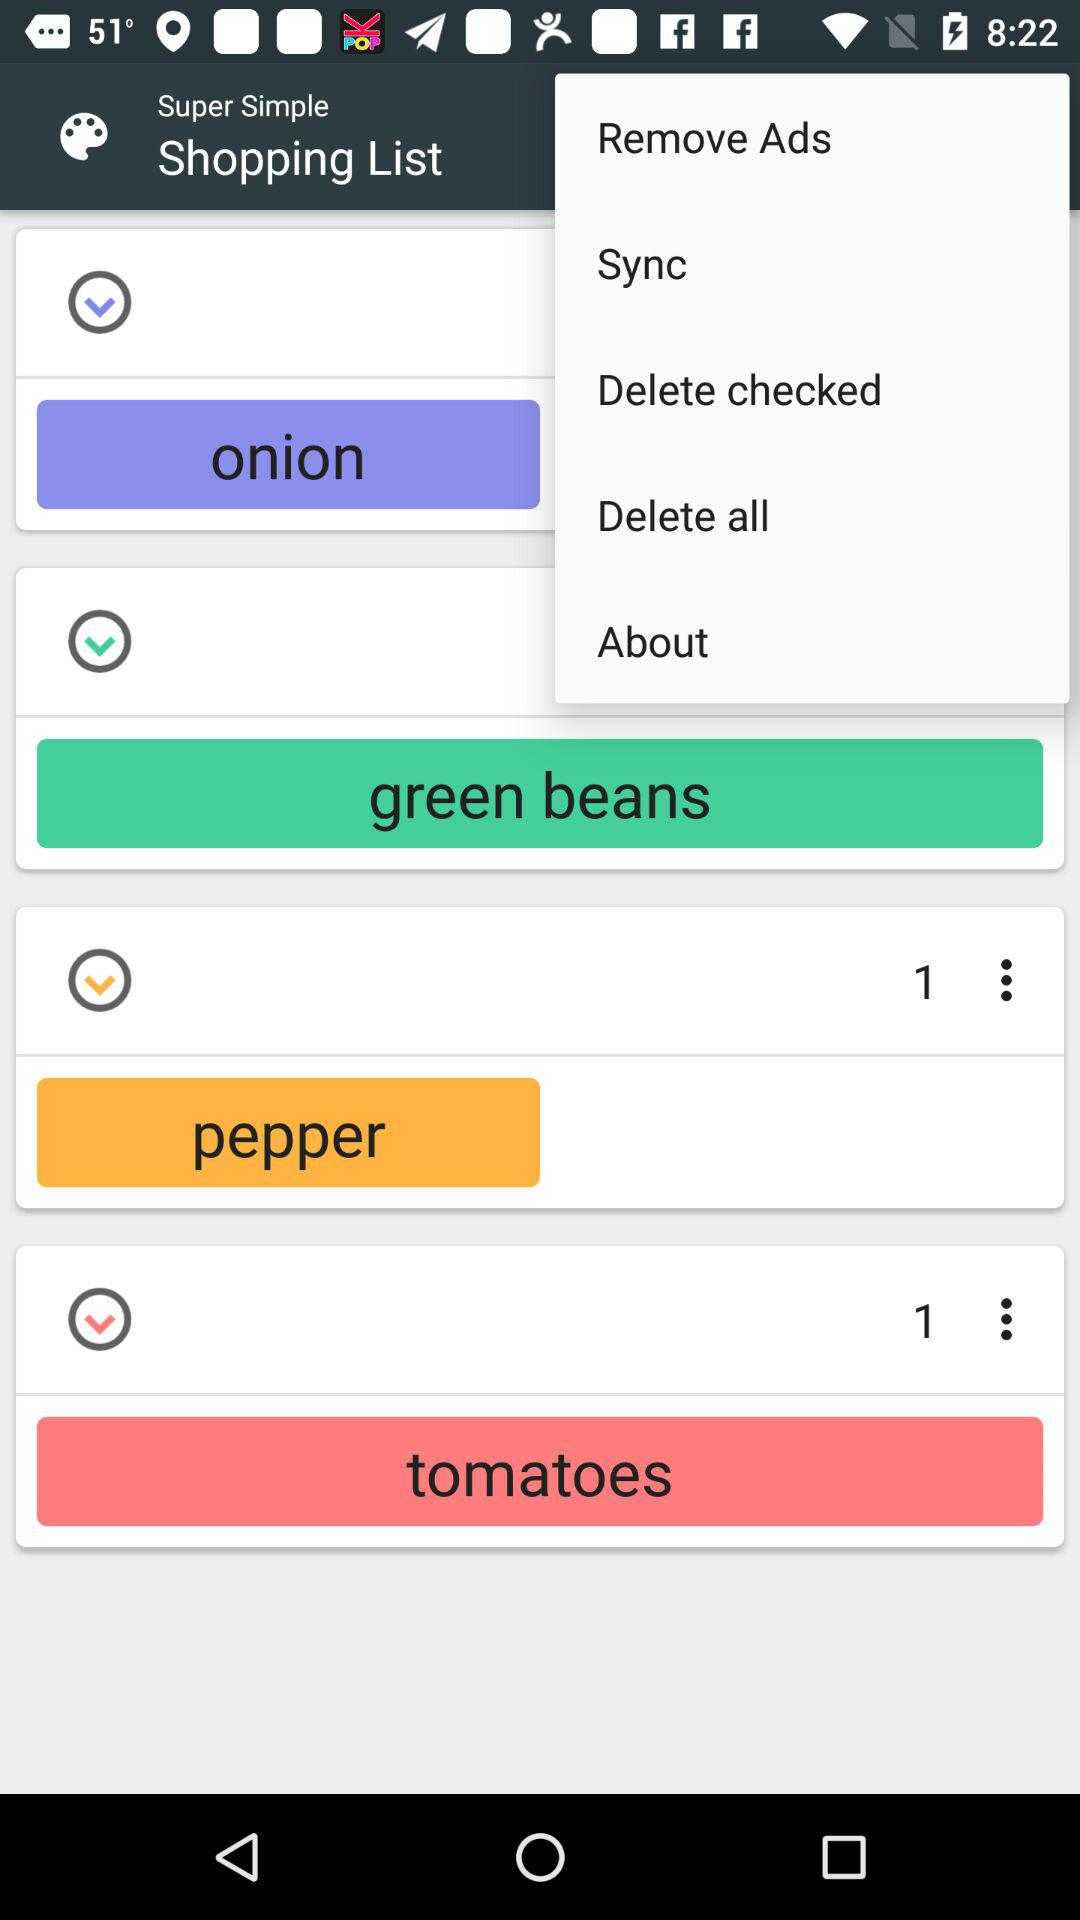How many items have a quantity of 1?
Answer the question using a single word or phrase. 2 